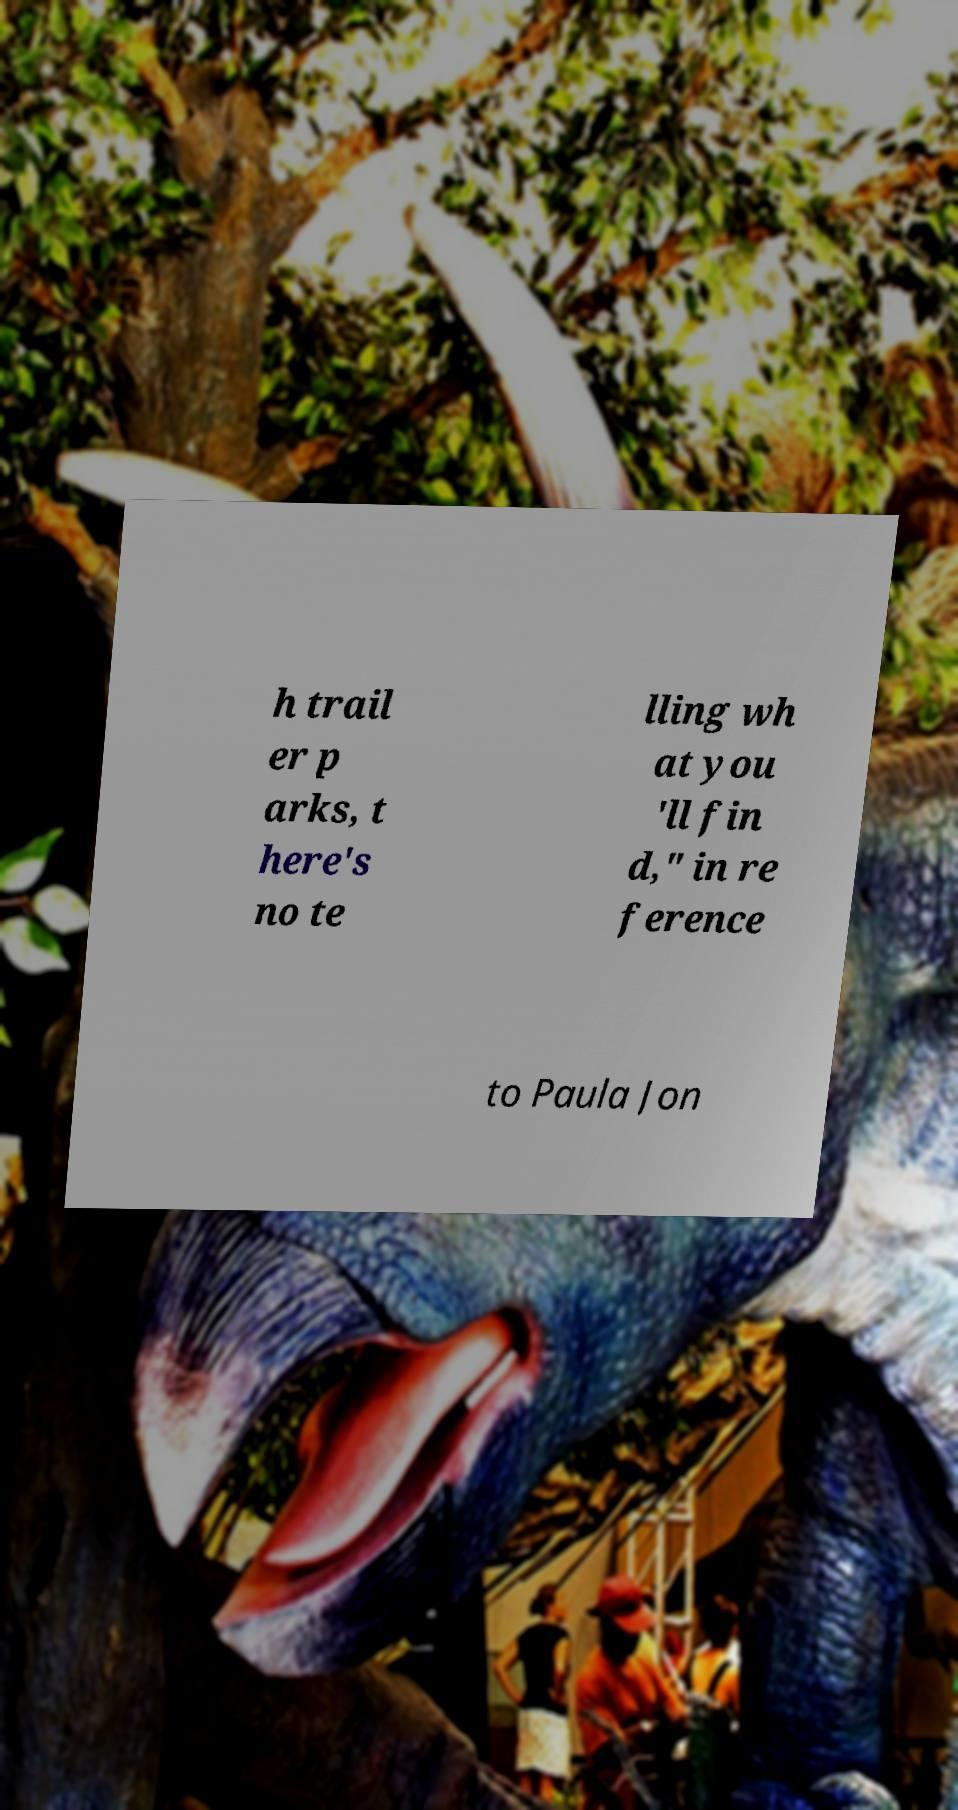There's text embedded in this image that I need extracted. Can you transcribe it verbatim? h trail er p arks, t here's no te lling wh at you 'll fin d," in re ference to Paula Jon 